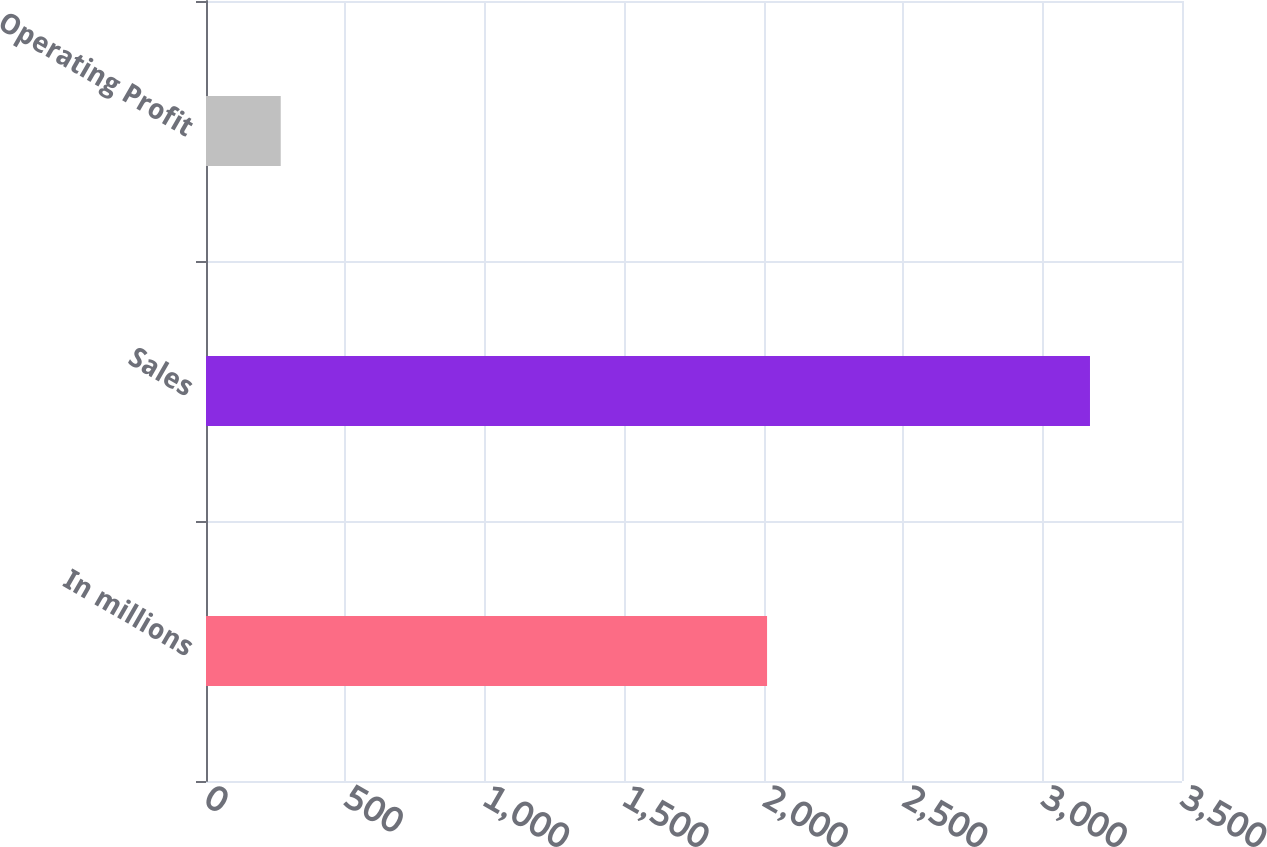<chart> <loc_0><loc_0><loc_500><loc_500><bar_chart><fcel>In millions<fcel>Sales<fcel>Operating Profit<nl><fcel>2012<fcel>3170<fcel>268<nl></chart> 